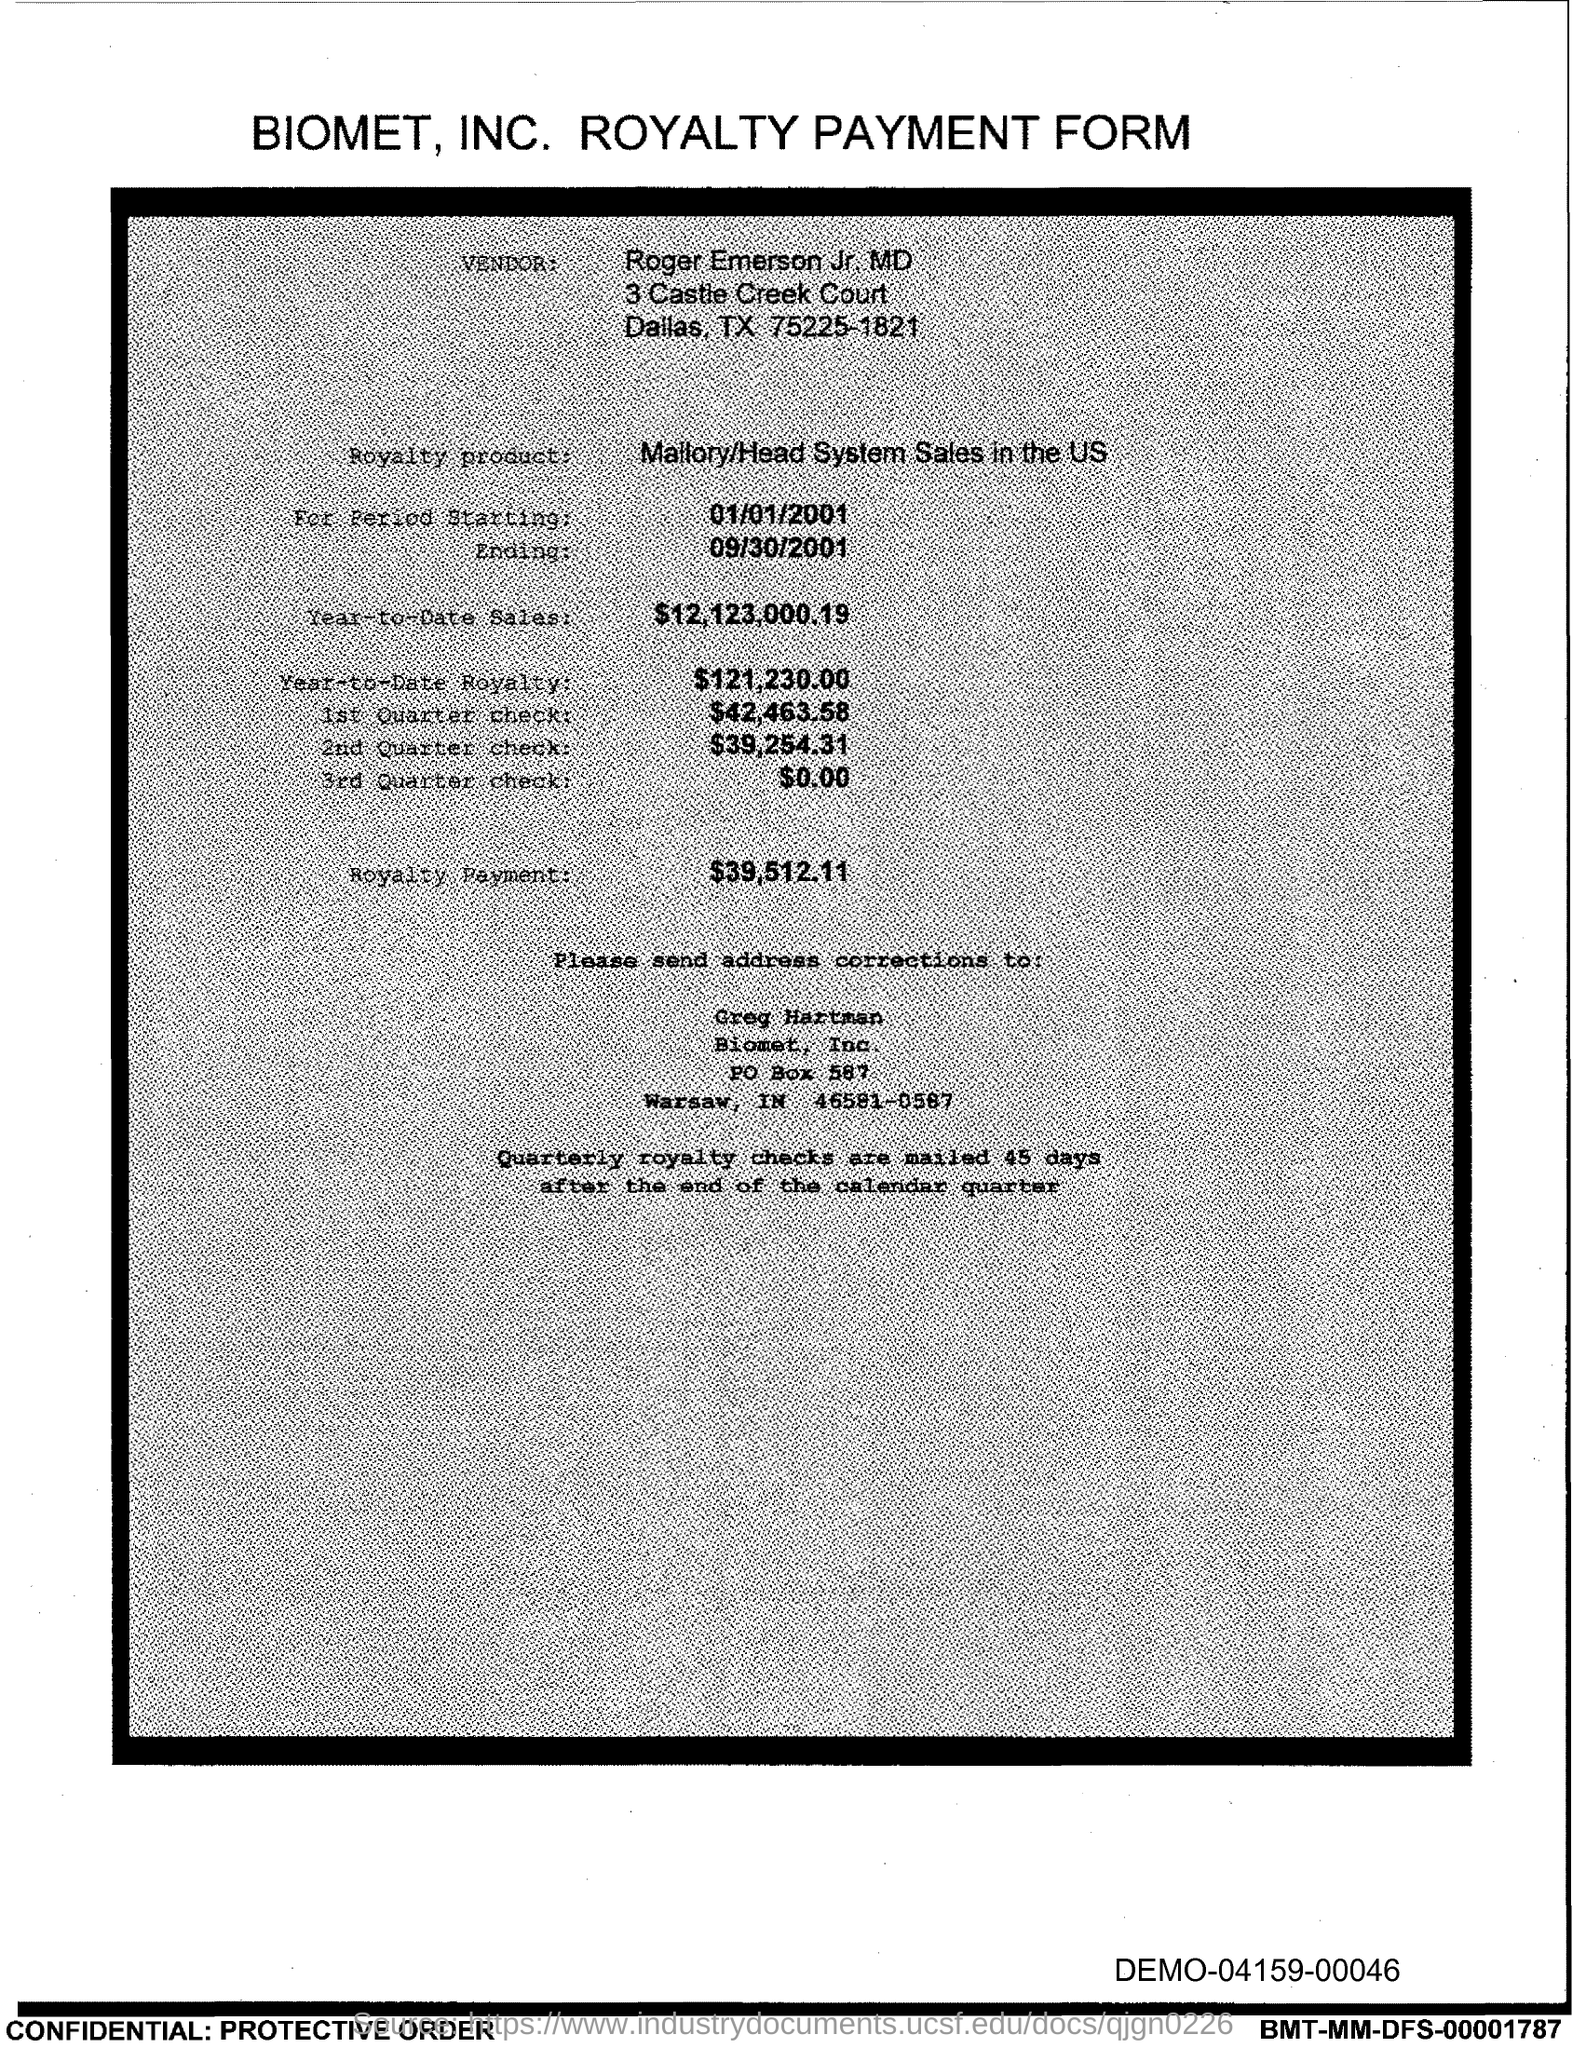Mention a couple of crucial points in this snapshot. The year-to-date sales up to the current point in time are $12,123,000.19. 